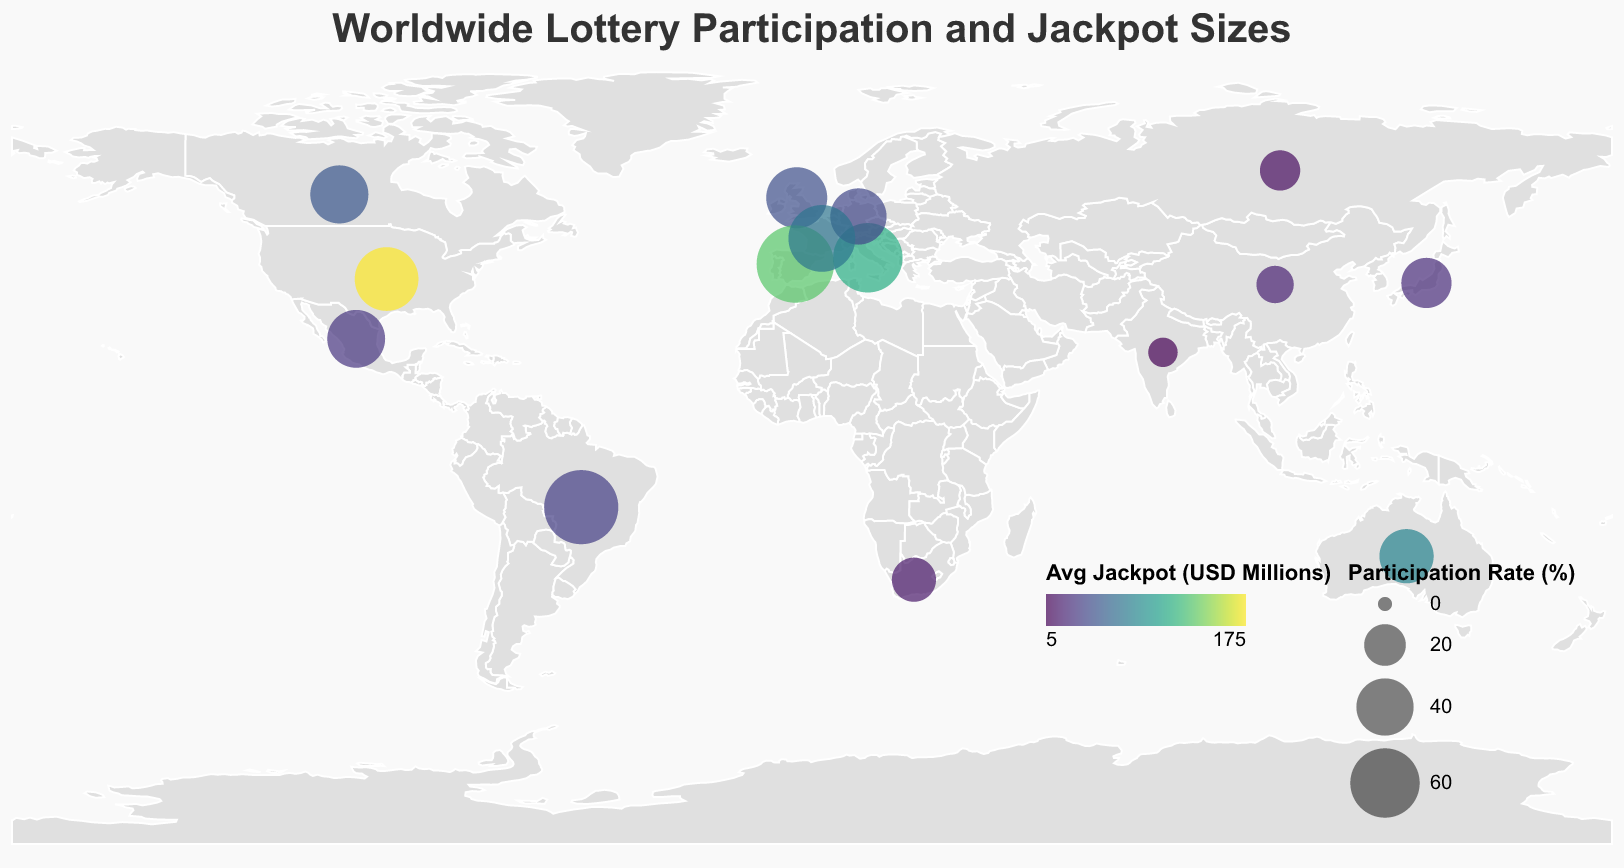What's the country with the highest lottery participation rate? The highest participation rate is displayed by the largest circle. By examining the figure, Spain has the largest circle indicating the highest rate.
Answer: Spain What is the participation rate in Japan? Locate Japan on the map (island country situated in East Asia) and observe the size of the circle. The specific participation rate is 30.2%.
Answer: 30.2% Which country has the highest average jackpot size and what is that value? Identify the country with the most intensely colored circle, indicating the highest average jackpot size. The United States is the most intensely colored, showing an average jackpot size of 175 million USD.
Answer: United States, 175 million USD What's the average participation rate of countries with an average jackpot size over 50 million USD? Identify countries with jackpot sizes over 50 million (United States, Spain, Australia, Italy, France), sum their participation rates (50.2 + 75.3 + 35.7 + 60.1 + 55.4 = 276.7), and divide by the number of countries (5). The calculation gives an average participation rate of 55.34%.
Answer: 55.34% Which country has a higher participation rate, Canada or Germany? Compare the sizes of the circles for Canada and Germany. Canada's circle is larger, indicating it has a higher participation rate.
Answer: Canada What is the combined average jackpot size of all countries with a participation rate below 20%? Identify countries with a participation rate below 20% (China, India, South Africa, Russia), sum their jackpot sizes (20 + 5 + 15 + 10 = 50). The combined average jackpot size is 50 million USD.
Answer: 50 million USD Which has a larger average jackpot size: Brazil or Mexico? Compare the color intensities of the circles for Brazil and Mexico. Brazil has a lighter shade compared to Mexico, indicating a smaller jackpot size.
Answer: Mexico What's the difference in participation rates between the United Kingdom and France? Subtract the participation rate of the United Kingdom (45.8%) from that of France (55.4%). The difference is 9.6%.
Answer: 9.6% Which country in the Americas has the least participation in the lottery? Identify and compare the circles in the Americas (United States, Brazil, Canada, Mexico). Mexico has the smallest circle, indicating the lowest participation rate.
Answer: Mexico 